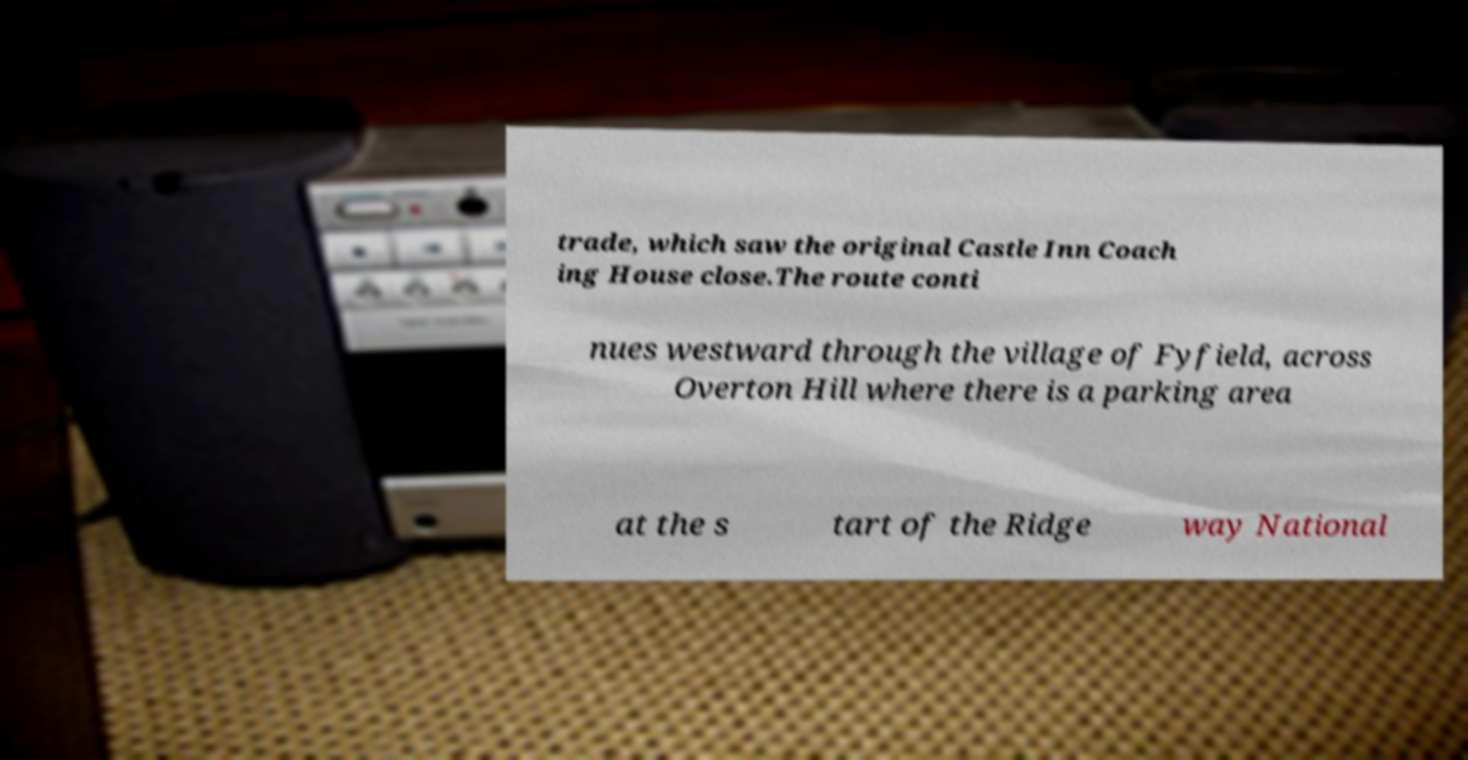I need the written content from this picture converted into text. Can you do that? trade, which saw the original Castle Inn Coach ing House close.The route conti nues westward through the village of Fyfield, across Overton Hill where there is a parking area at the s tart of the Ridge way National 